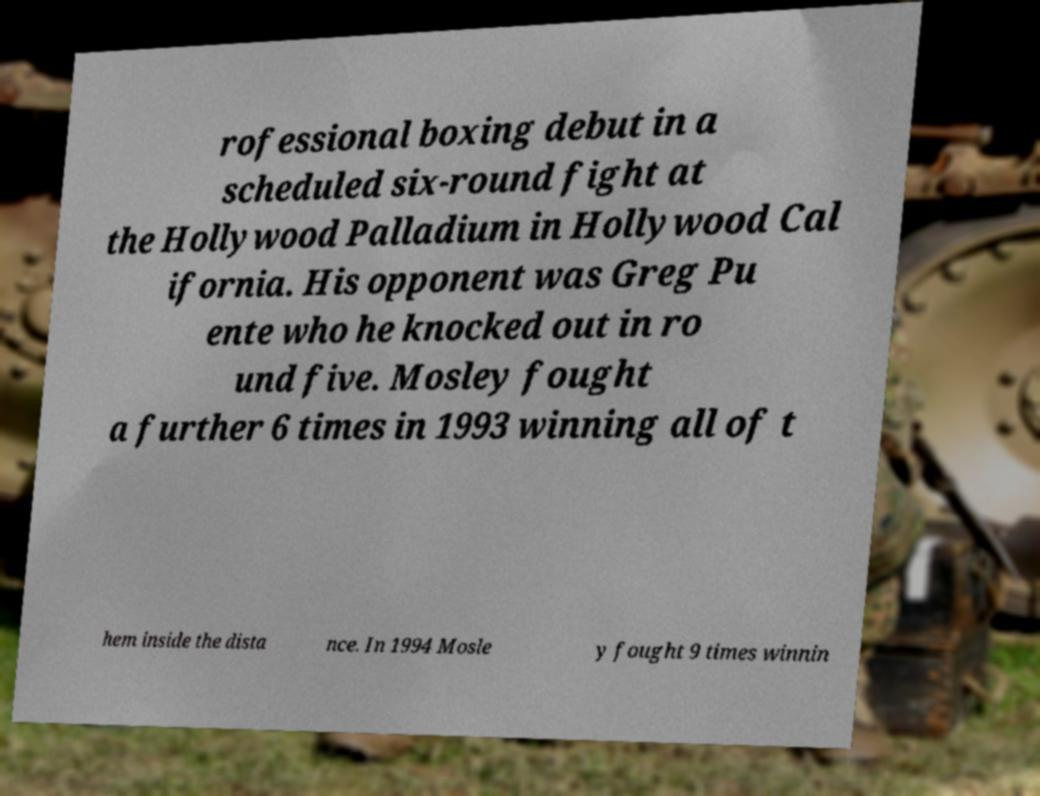Can you accurately transcribe the text from the provided image for me? rofessional boxing debut in a scheduled six-round fight at the Hollywood Palladium in Hollywood Cal ifornia. His opponent was Greg Pu ente who he knocked out in ro und five. Mosley fought a further 6 times in 1993 winning all of t hem inside the dista nce. In 1994 Mosle y fought 9 times winnin 